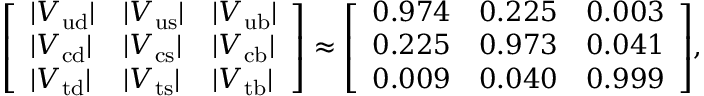<formula> <loc_0><loc_0><loc_500><loc_500>{ \left [ \begin{array} { l l l } { | V _ { u d } | } & { | V _ { u s } | } & { | V _ { u b } | } \\ { | V _ { c d } | } & { | V _ { c s } | } & { | V _ { c b } | } \\ { | V _ { t d } | } & { | V _ { t s } | } & { | V _ { t b } | } \end{array} \right ] } \approx { \left [ \begin{array} { l l l } { 0 . 9 7 4 } & { 0 . 2 2 5 } & { 0 . 0 0 3 } \\ { 0 . 2 2 5 } & { 0 . 9 7 3 } & { 0 . 0 4 1 } \\ { 0 . 0 0 9 } & { 0 . 0 4 0 } & { 0 . 9 9 9 } \end{array} \right ] } ,</formula> 